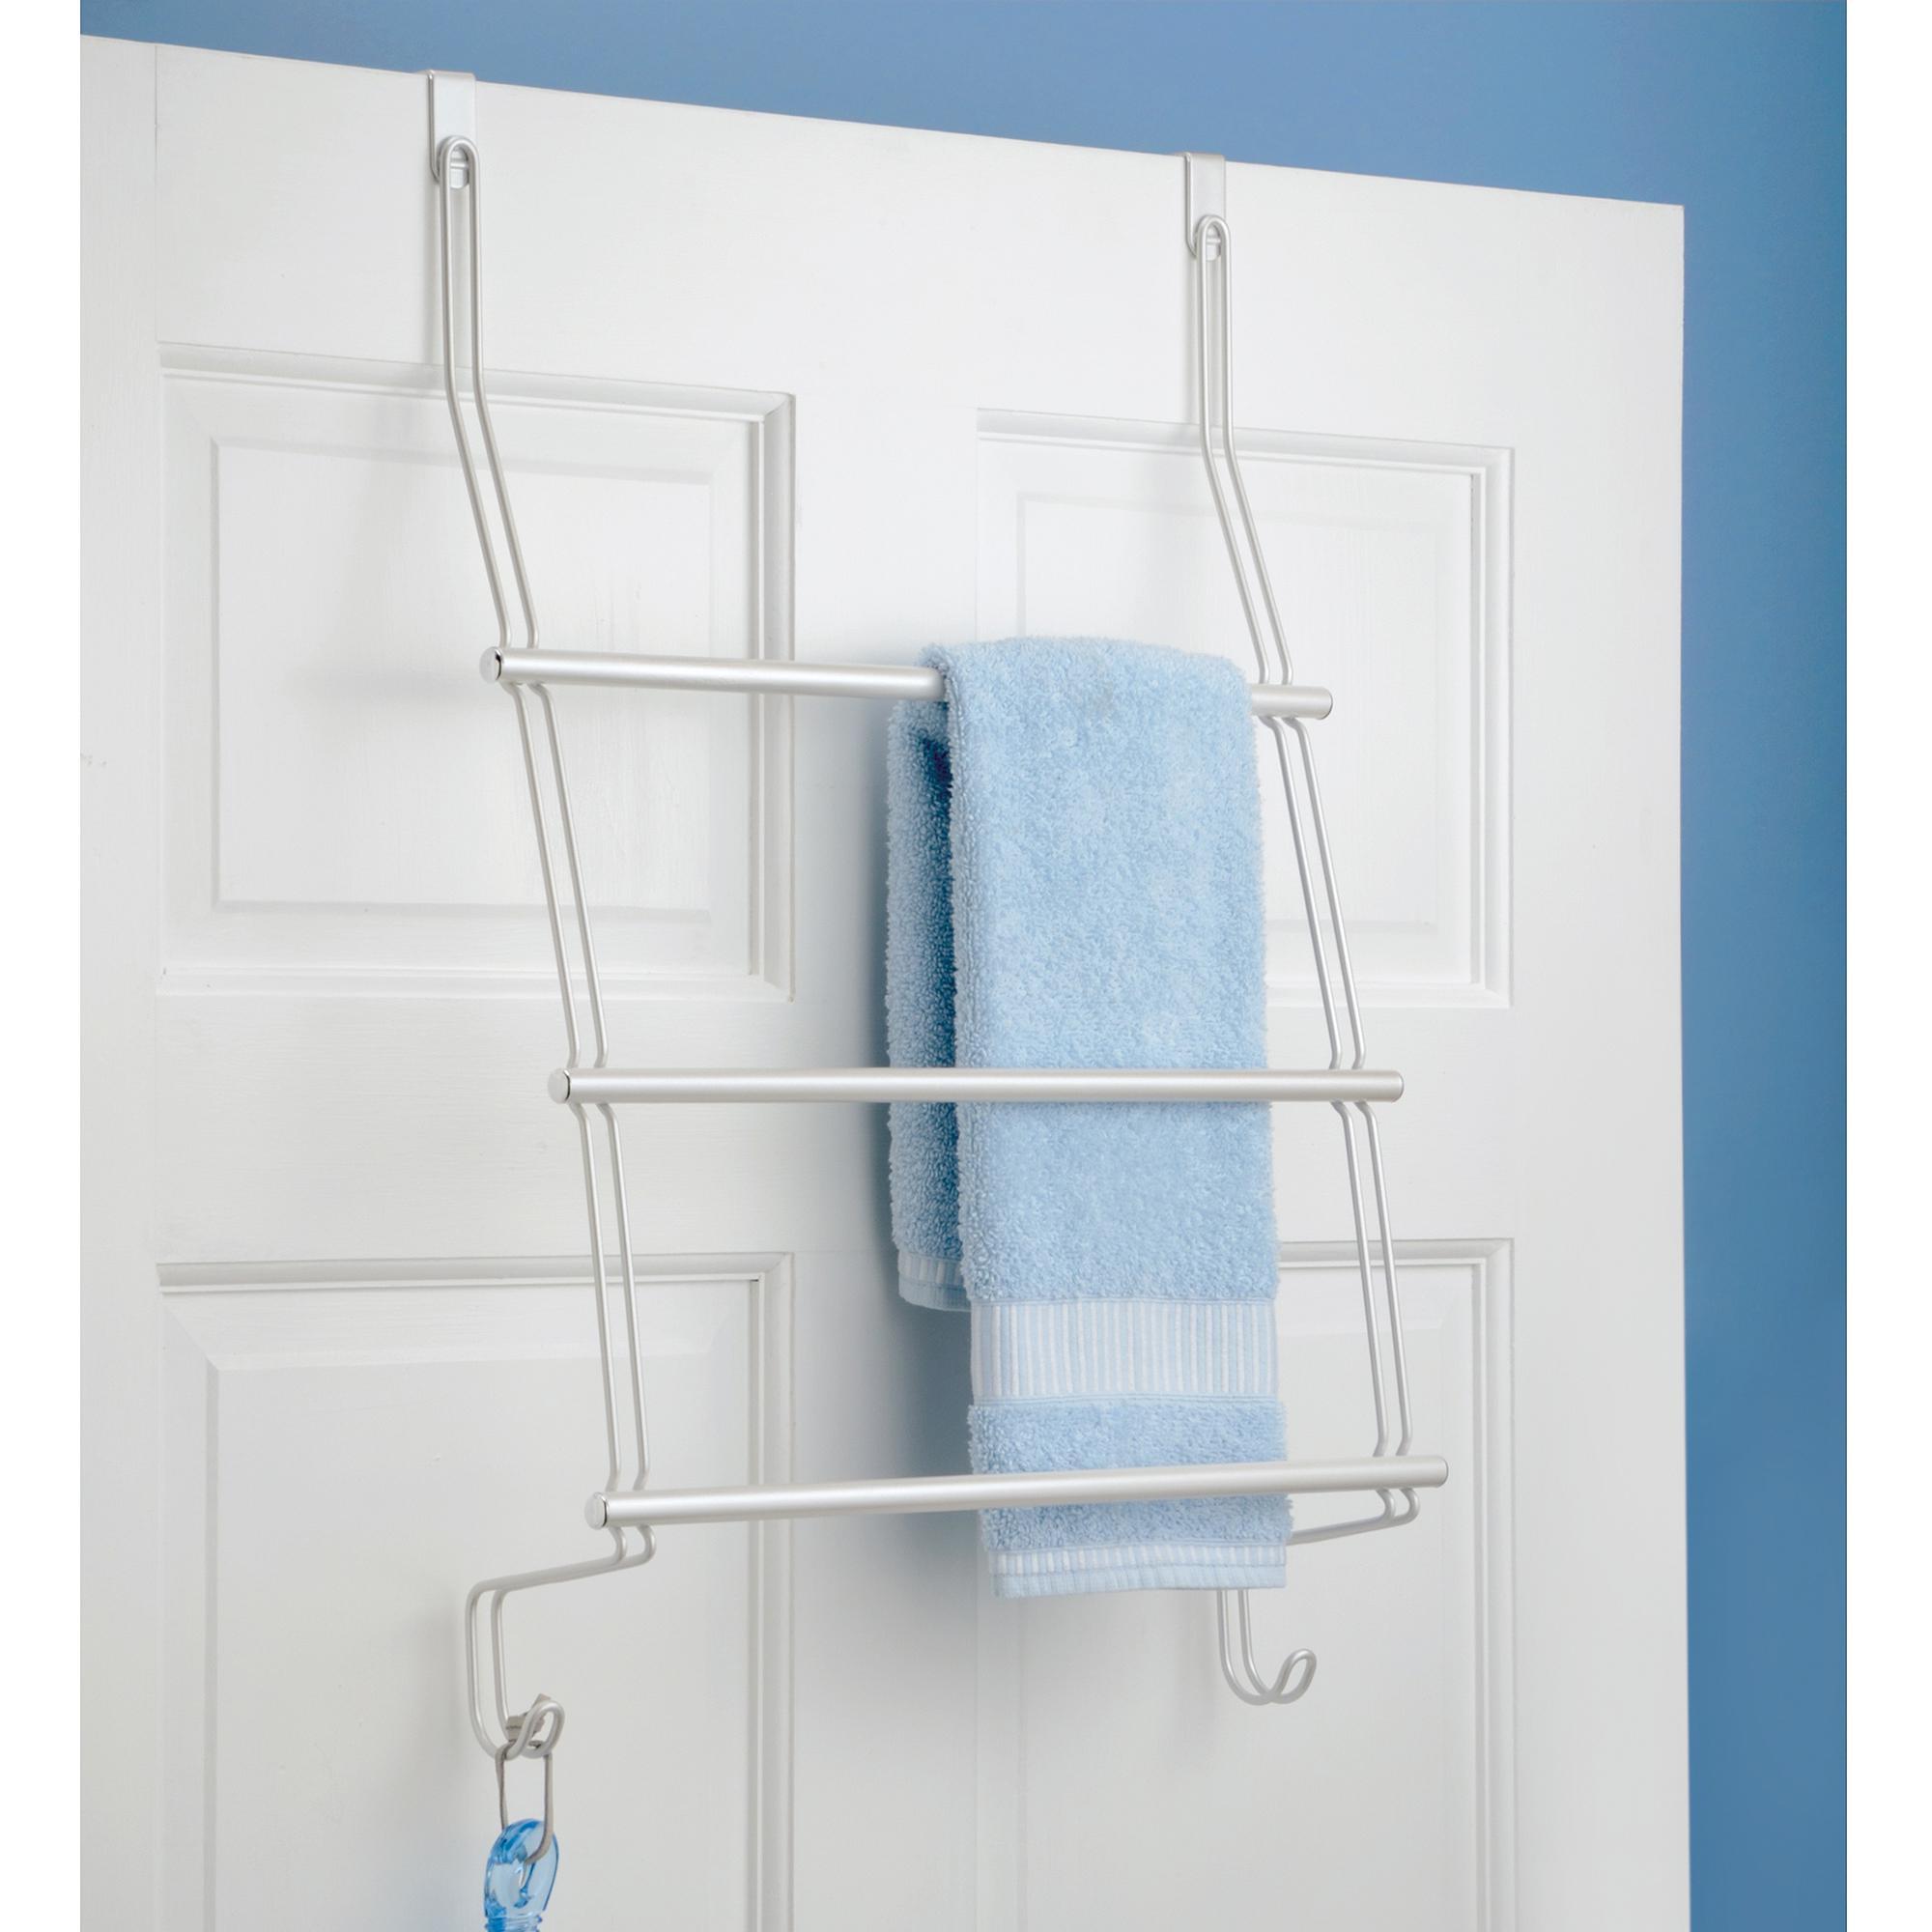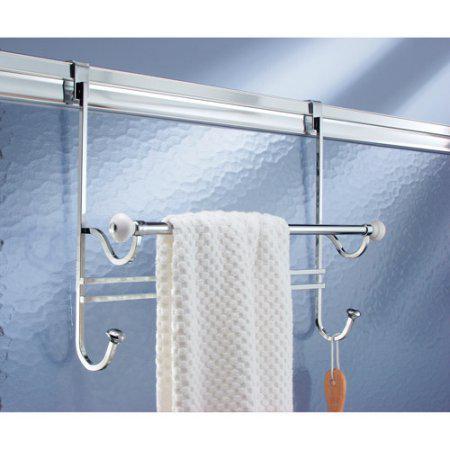The first image is the image on the left, the second image is the image on the right. Given the left and right images, does the statement "An image shows a light blue towel hanging on an over-the-door rack." hold true? Answer yes or no. Yes. The first image is the image on the left, the second image is the image on the right. Examine the images to the left and right. Is the description "There is a blue towel hanging on an over the door rack" accurate? Answer yes or no. Yes. 